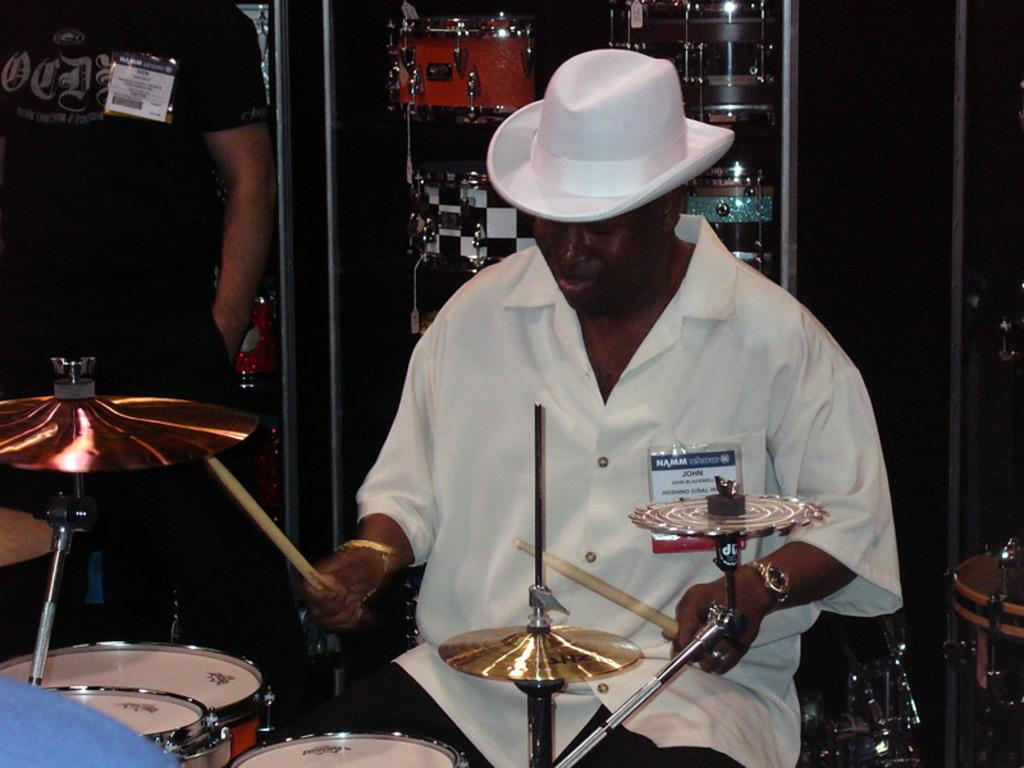What is the main subject of the image? There is a person sitting at musical instruments in the center of the image. Can you describe the person's position in relation to the musical instruments? The person is sitting at the musical instruments. What else can be seen on the left side of the image? There is a man on the left side of the image. Are there any musical instruments visible in the background? Yes, there are musical instruments visible in the background. What type of doll can be seen rubbing the waves in the image? There is no doll or waves present in the image. 